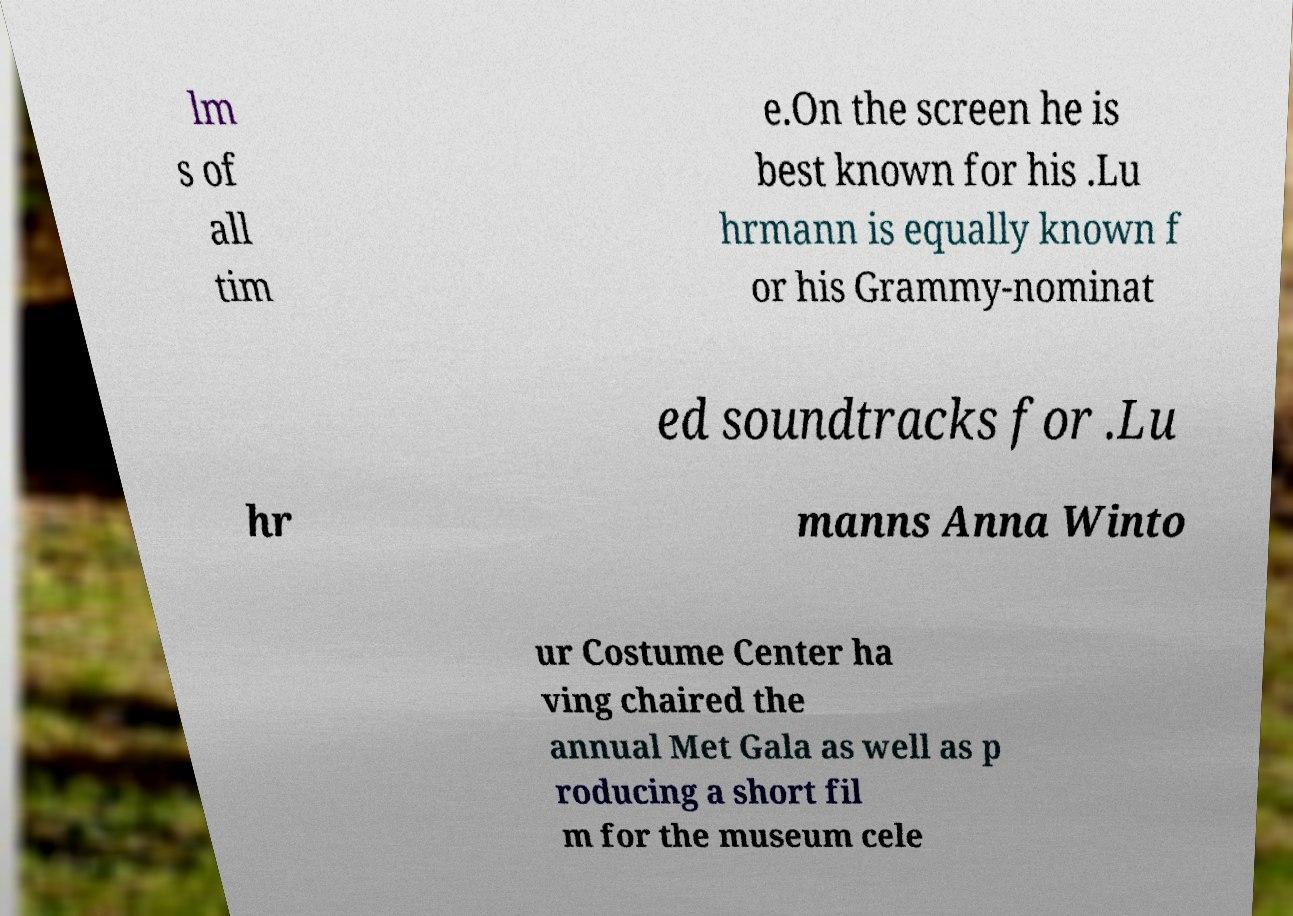Can you read and provide the text displayed in the image?This photo seems to have some interesting text. Can you extract and type it out for me? lm s of all tim e.On the screen he is best known for his .Lu hrmann is equally known f or his Grammy-nominat ed soundtracks for .Lu hr manns Anna Winto ur Costume Center ha ving chaired the annual Met Gala as well as p roducing a short fil m for the museum cele 